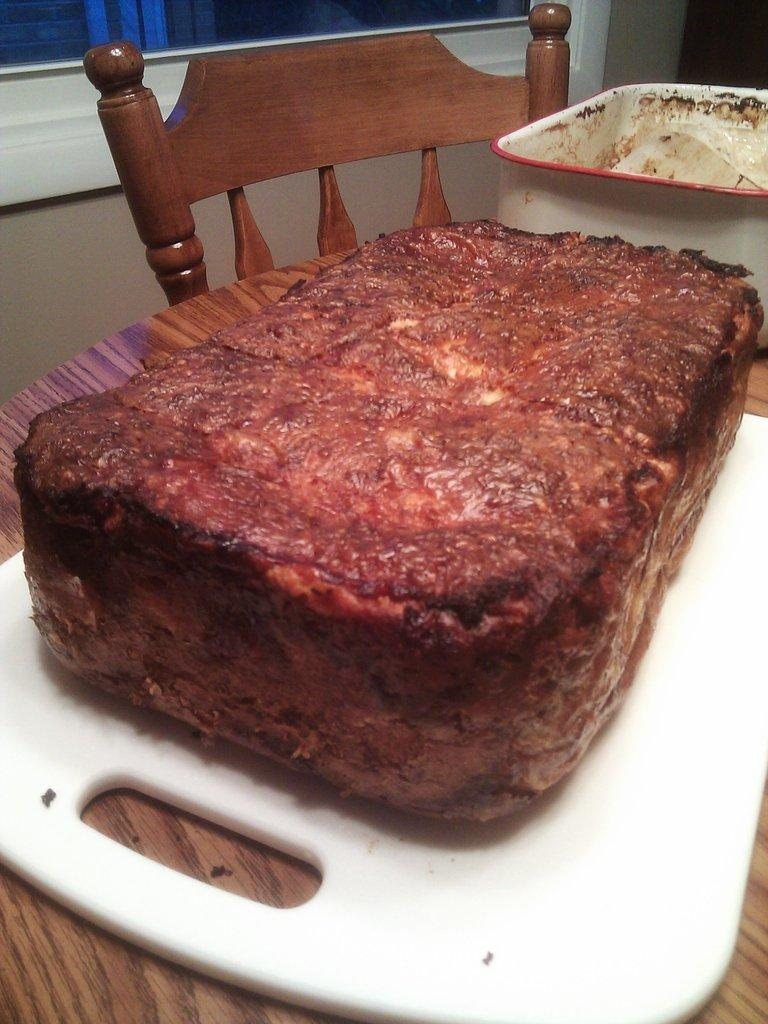What piece of furniture is in the image? There is a table in the image. What is located next to the table? There is a chair beside the table. What objects are on the table? There is a plate and a bowl on the table. What can be seen behind the chair? There is a window at the back of the chair. What type of veil can be seen hanging from the window in the image? There is no veil present in the image; only a window is visible behind the chair. 